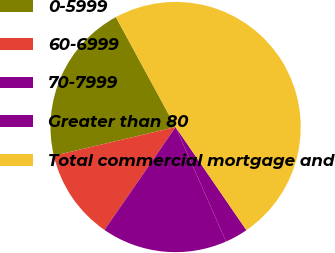<chart> <loc_0><loc_0><loc_500><loc_500><pie_chart><fcel>0-5999<fcel>60-6999<fcel>70-7999<fcel>Greater than 80<fcel>Total commercial mortgage and<nl><fcel>20.77%<fcel>11.69%<fcel>16.23%<fcel>2.97%<fcel>48.35%<nl></chart> 